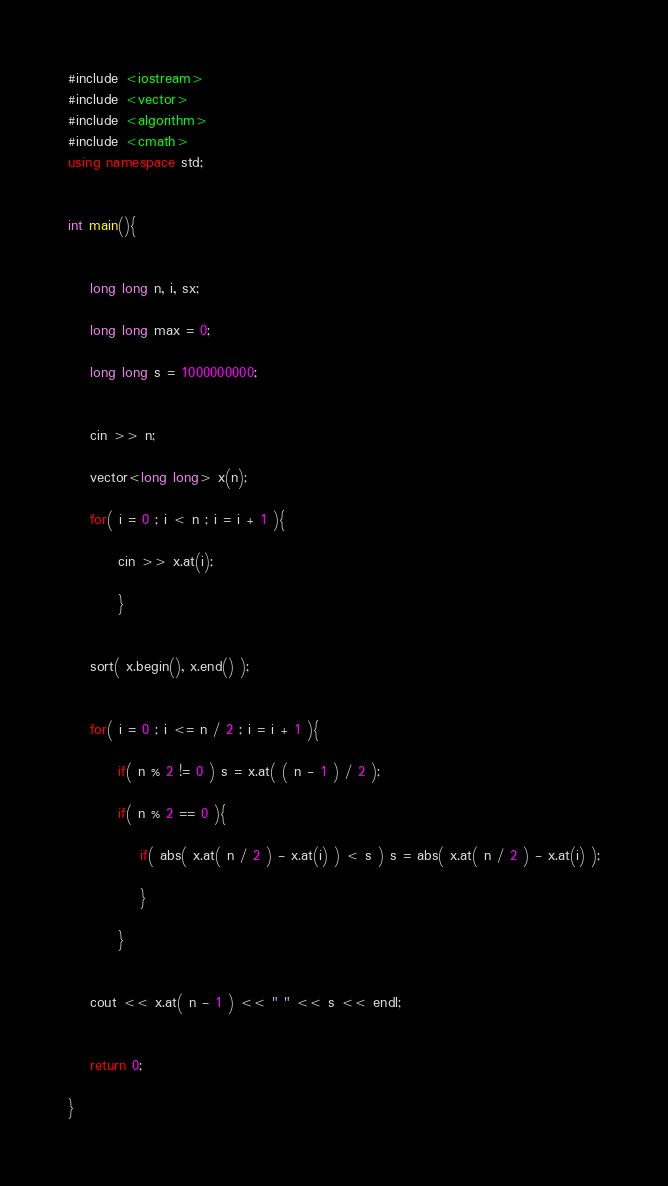Convert code to text. <code><loc_0><loc_0><loc_500><loc_500><_C++_>#include <iostream>
#include <vector>
#include <algorithm>
#include <cmath>
using namespace std;
                                                                                                
  
int main(){
                                                                                                
   
    long long n, i, sx;

    long long max = 0;

    long long s = 1000000000;
   
      
    cin >> n;
   
    vector<long long> x(n);

    for( i = 0 ; i < n ; i = i + 1 ){

         cin >> x.at(i);

         }
   

    sort( x.begin(), x.end() );


    for( i = 0 ; i <= n / 2 ; i = i + 1 ){

         if( n % 2 != 0 ) s = x.at( ( n - 1 ) / 2 );

         if( n % 2 == 0 ){

             if( abs( x.at( n / 2 ) - x.at(i) ) < s ) s = abs( x.at( n / 2 ) - x.at(i) );

             }             

         }


    cout << x.at( n - 1 ) << " " << s << endl;


    return 0;
                                                          
}</code> 